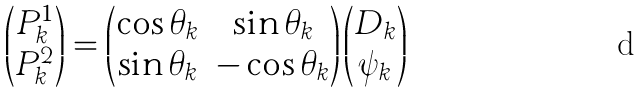<formula> <loc_0><loc_0><loc_500><loc_500>\begin{pmatrix} P _ { k } ^ { 1 } \\ P _ { k } ^ { 2 } \end{pmatrix} = \begin{pmatrix} \cos \theta _ { k } & \sin \theta _ { k } \\ \sin \theta _ { k } & - \cos \theta _ { k } \end{pmatrix} \begin{pmatrix} D _ { k } \\ \psi _ { k } \end{pmatrix}</formula> 